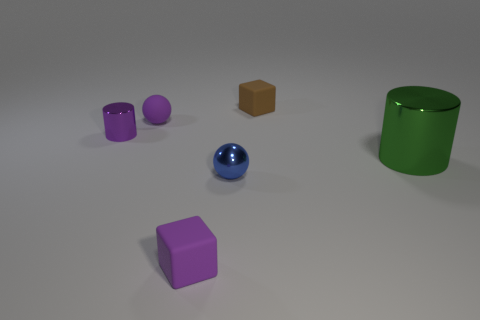Add 3 tiny purple objects. How many objects exist? 9 Add 5 tiny purple metal cylinders. How many tiny purple metal cylinders exist? 6 Subtract 0 yellow cylinders. How many objects are left? 6 Subtract all tiny purple cylinders. Subtract all tiny purple rubber things. How many objects are left? 3 Add 6 small purple blocks. How many small purple blocks are left? 7 